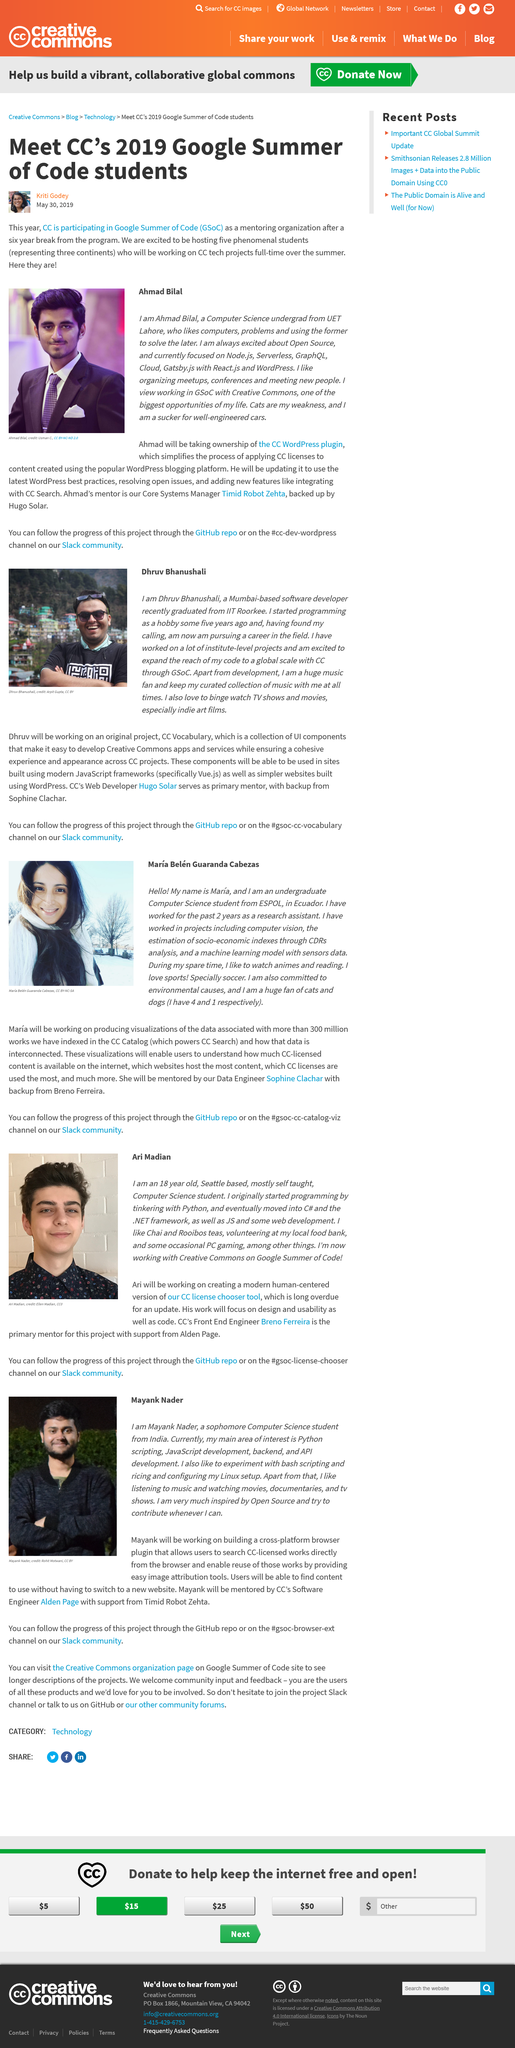Give some essential details in this illustration. Ahmad's weakness is his undeniable love and affection for cats. The person in the photograph on the left is Mayank Nader. Ari enjoys drinking both Chai and Rooibos teas. The primary mentor for the project of creating a modern human-centered version of the CC license chooser tool is Breno Ferreira. Maria has a total of 4 cats. 